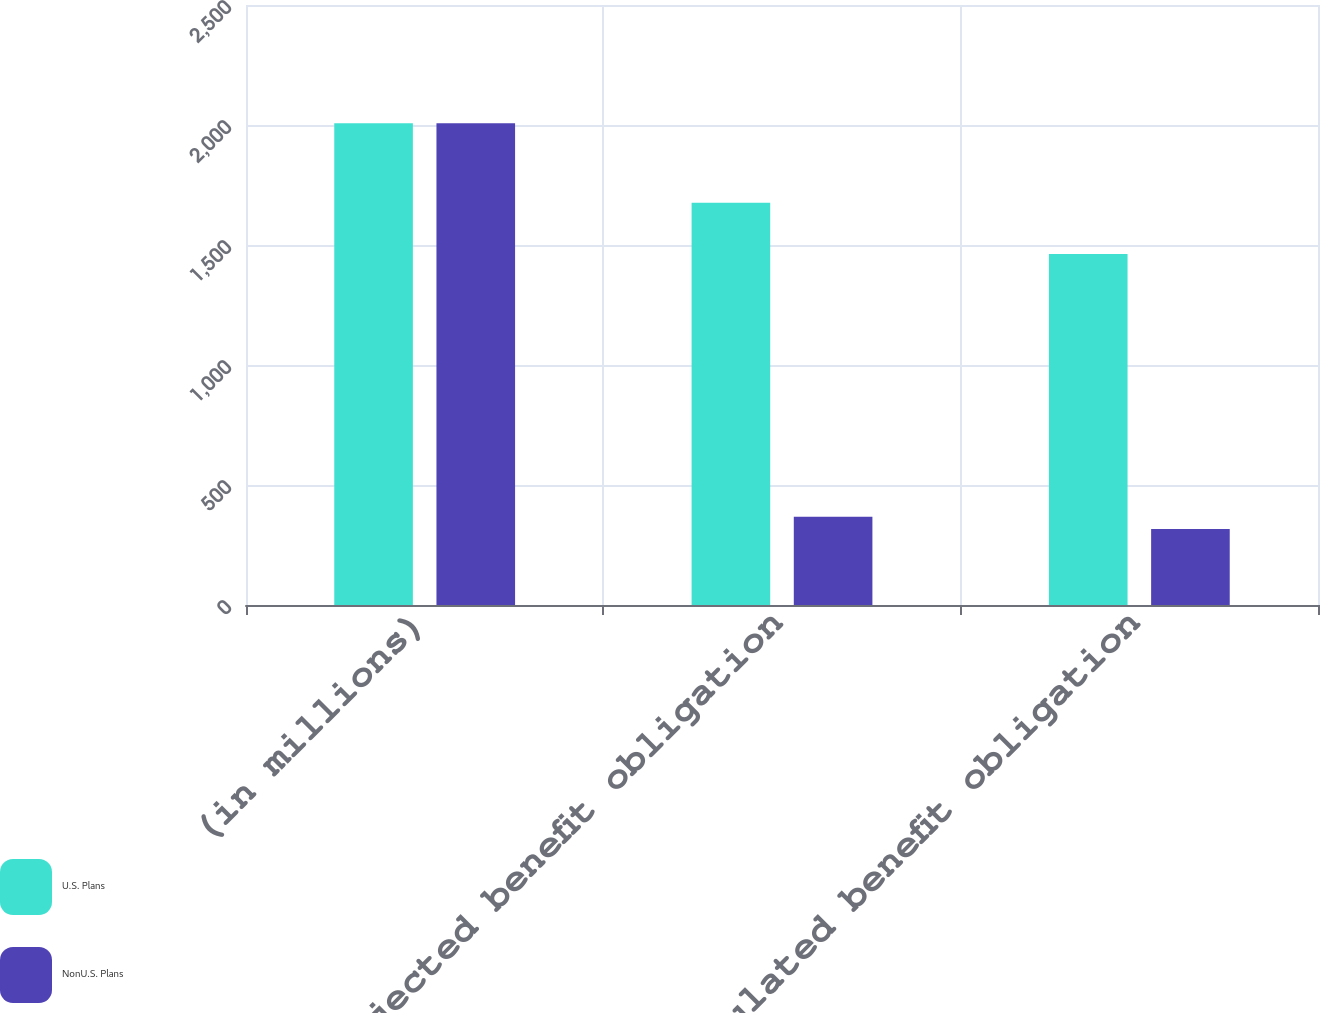Convert chart to OTSL. <chart><loc_0><loc_0><loc_500><loc_500><stacked_bar_chart><ecel><fcel>(in millions)<fcel>Projected benefit obligation<fcel>Accumulated benefit obligation<nl><fcel>U.S. Plans<fcel>2007<fcel>1676<fcel>1462<nl><fcel>NonU.S. Plans<fcel>2007<fcel>368<fcel>317<nl></chart> 